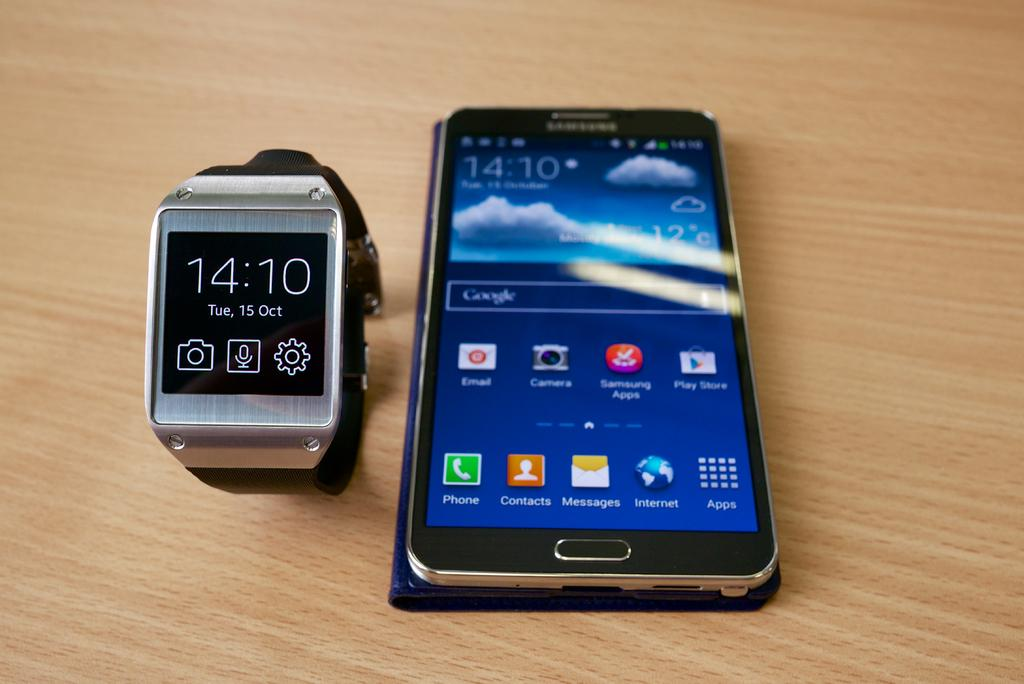<image>
Write a terse but informative summary of the picture. A cell phone that says Samsung is next to a silver smart watch on a wooden table. 